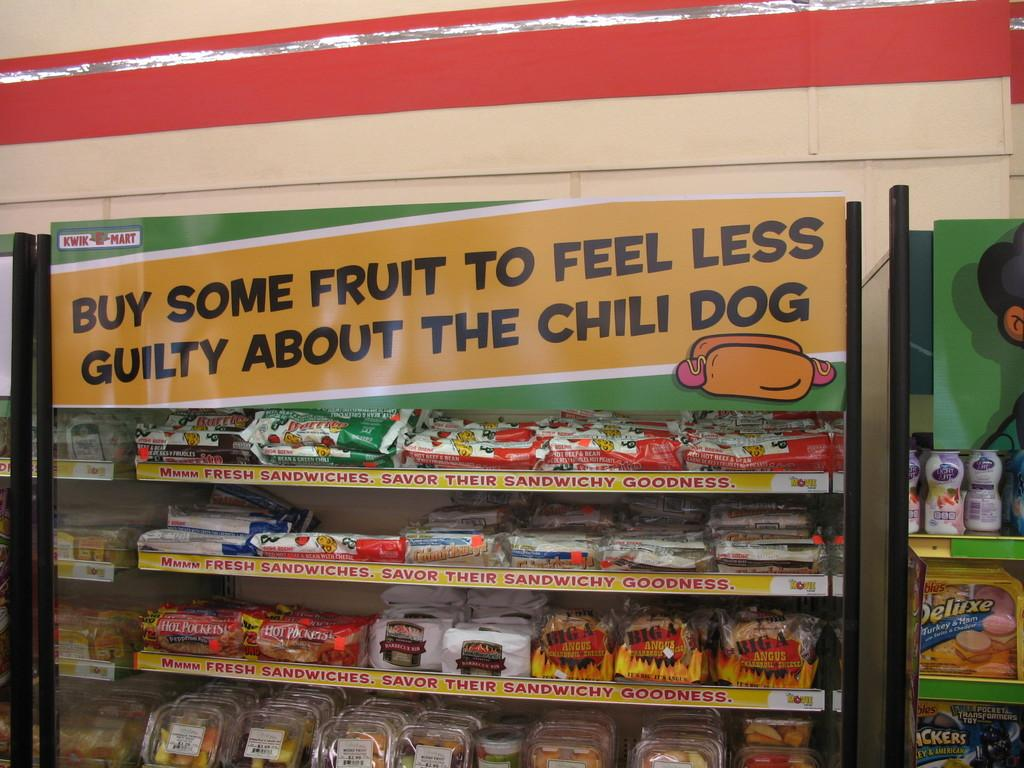Provide a one-sentence caption for the provided image. A display case with rows of sandwiches in wrappers. 